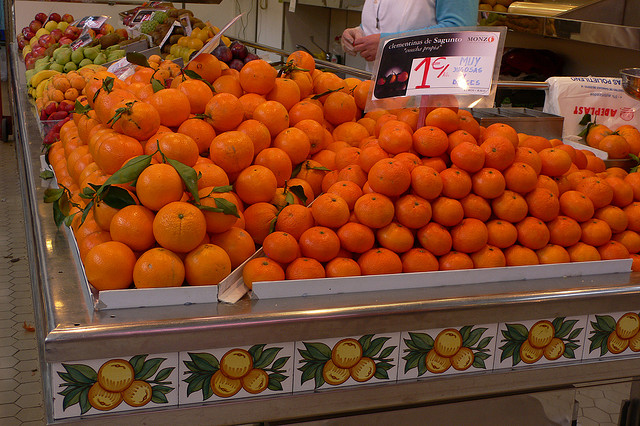<image>What type of vegetable is pictured? There is no vegetable pictured in the image. It might be an orange or apple. What type of vegetable is pictured? It is ambiguous what type of vegetable is pictured. It can be seen as oranges or mandarin orange apple. 